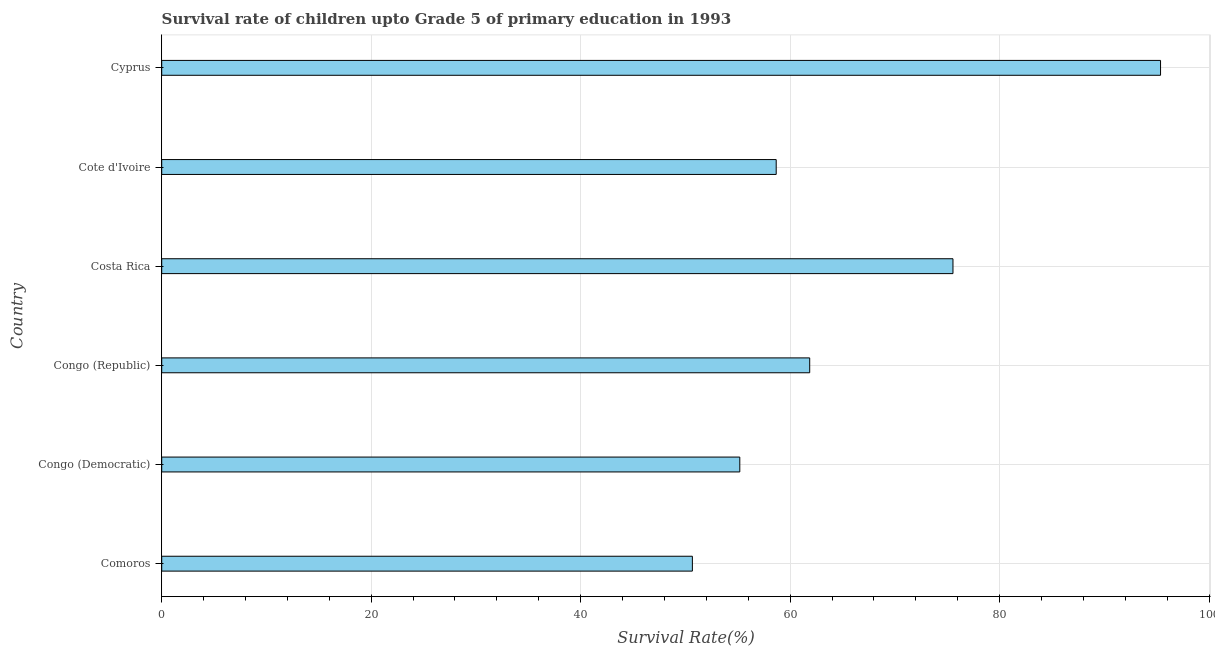Does the graph contain grids?
Your response must be concise. Yes. What is the title of the graph?
Ensure brevity in your answer.  Survival rate of children upto Grade 5 of primary education in 1993 . What is the label or title of the X-axis?
Your response must be concise. Survival Rate(%). What is the label or title of the Y-axis?
Your answer should be very brief. Country. What is the survival rate in Cyprus?
Offer a very short reply. 95.36. Across all countries, what is the maximum survival rate?
Make the answer very short. 95.36. Across all countries, what is the minimum survival rate?
Offer a terse response. 50.67. In which country was the survival rate maximum?
Your answer should be compact. Cyprus. In which country was the survival rate minimum?
Make the answer very short. Comoros. What is the sum of the survival rate?
Your response must be concise. 397.3. What is the difference between the survival rate in Congo (Democratic) and Cote d'Ivoire?
Provide a succinct answer. -3.48. What is the average survival rate per country?
Provide a succinct answer. 66.22. What is the median survival rate?
Provide a short and direct response. 60.27. What is the ratio of the survival rate in Congo (Republic) to that in Cyprus?
Your answer should be very brief. 0.65. What is the difference between the highest and the second highest survival rate?
Ensure brevity in your answer.  19.82. What is the difference between the highest and the lowest survival rate?
Your answer should be compact. 44.7. In how many countries, is the survival rate greater than the average survival rate taken over all countries?
Your response must be concise. 2. How many bars are there?
Your answer should be very brief. 6. Are all the bars in the graph horizontal?
Provide a succinct answer. Yes. How many countries are there in the graph?
Give a very brief answer. 6. What is the difference between two consecutive major ticks on the X-axis?
Offer a very short reply. 20. Are the values on the major ticks of X-axis written in scientific E-notation?
Offer a terse response. No. What is the Survival Rate(%) of Comoros?
Keep it short and to the point. 50.67. What is the Survival Rate(%) of Congo (Democratic)?
Make the answer very short. 55.19. What is the Survival Rate(%) of Congo (Republic)?
Ensure brevity in your answer.  61.87. What is the Survival Rate(%) of Costa Rica?
Your response must be concise. 75.55. What is the Survival Rate(%) of Cote d'Ivoire?
Make the answer very short. 58.67. What is the Survival Rate(%) of Cyprus?
Make the answer very short. 95.36. What is the difference between the Survival Rate(%) in Comoros and Congo (Democratic)?
Give a very brief answer. -4.53. What is the difference between the Survival Rate(%) in Comoros and Congo (Republic)?
Provide a short and direct response. -11.2. What is the difference between the Survival Rate(%) in Comoros and Costa Rica?
Keep it short and to the point. -24.88. What is the difference between the Survival Rate(%) in Comoros and Cote d'Ivoire?
Offer a very short reply. -8. What is the difference between the Survival Rate(%) in Comoros and Cyprus?
Offer a very short reply. -44.7. What is the difference between the Survival Rate(%) in Congo (Democratic) and Congo (Republic)?
Keep it short and to the point. -6.67. What is the difference between the Survival Rate(%) in Congo (Democratic) and Costa Rica?
Offer a very short reply. -20.35. What is the difference between the Survival Rate(%) in Congo (Democratic) and Cote d'Ivoire?
Offer a terse response. -3.48. What is the difference between the Survival Rate(%) in Congo (Democratic) and Cyprus?
Offer a very short reply. -40.17. What is the difference between the Survival Rate(%) in Congo (Republic) and Costa Rica?
Your answer should be very brief. -13.68. What is the difference between the Survival Rate(%) in Congo (Republic) and Cote d'Ivoire?
Your response must be concise. 3.2. What is the difference between the Survival Rate(%) in Congo (Republic) and Cyprus?
Offer a very short reply. -33.5. What is the difference between the Survival Rate(%) in Costa Rica and Cote d'Ivoire?
Keep it short and to the point. 16.88. What is the difference between the Survival Rate(%) in Costa Rica and Cyprus?
Keep it short and to the point. -19.82. What is the difference between the Survival Rate(%) in Cote d'Ivoire and Cyprus?
Provide a short and direct response. -36.7. What is the ratio of the Survival Rate(%) in Comoros to that in Congo (Democratic)?
Offer a terse response. 0.92. What is the ratio of the Survival Rate(%) in Comoros to that in Congo (Republic)?
Offer a very short reply. 0.82. What is the ratio of the Survival Rate(%) in Comoros to that in Costa Rica?
Provide a short and direct response. 0.67. What is the ratio of the Survival Rate(%) in Comoros to that in Cote d'Ivoire?
Your answer should be compact. 0.86. What is the ratio of the Survival Rate(%) in Comoros to that in Cyprus?
Offer a terse response. 0.53. What is the ratio of the Survival Rate(%) in Congo (Democratic) to that in Congo (Republic)?
Provide a short and direct response. 0.89. What is the ratio of the Survival Rate(%) in Congo (Democratic) to that in Costa Rica?
Your response must be concise. 0.73. What is the ratio of the Survival Rate(%) in Congo (Democratic) to that in Cote d'Ivoire?
Your answer should be very brief. 0.94. What is the ratio of the Survival Rate(%) in Congo (Democratic) to that in Cyprus?
Offer a very short reply. 0.58. What is the ratio of the Survival Rate(%) in Congo (Republic) to that in Costa Rica?
Ensure brevity in your answer.  0.82. What is the ratio of the Survival Rate(%) in Congo (Republic) to that in Cote d'Ivoire?
Your response must be concise. 1.05. What is the ratio of the Survival Rate(%) in Congo (Republic) to that in Cyprus?
Offer a terse response. 0.65. What is the ratio of the Survival Rate(%) in Costa Rica to that in Cote d'Ivoire?
Give a very brief answer. 1.29. What is the ratio of the Survival Rate(%) in Costa Rica to that in Cyprus?
Provide a short and direct response. 0.79. What is the ratio of the Survival Rate(%) in Cote d'Ivoire to that in Cyprus?
Your answer should be very brief. 0.61. 